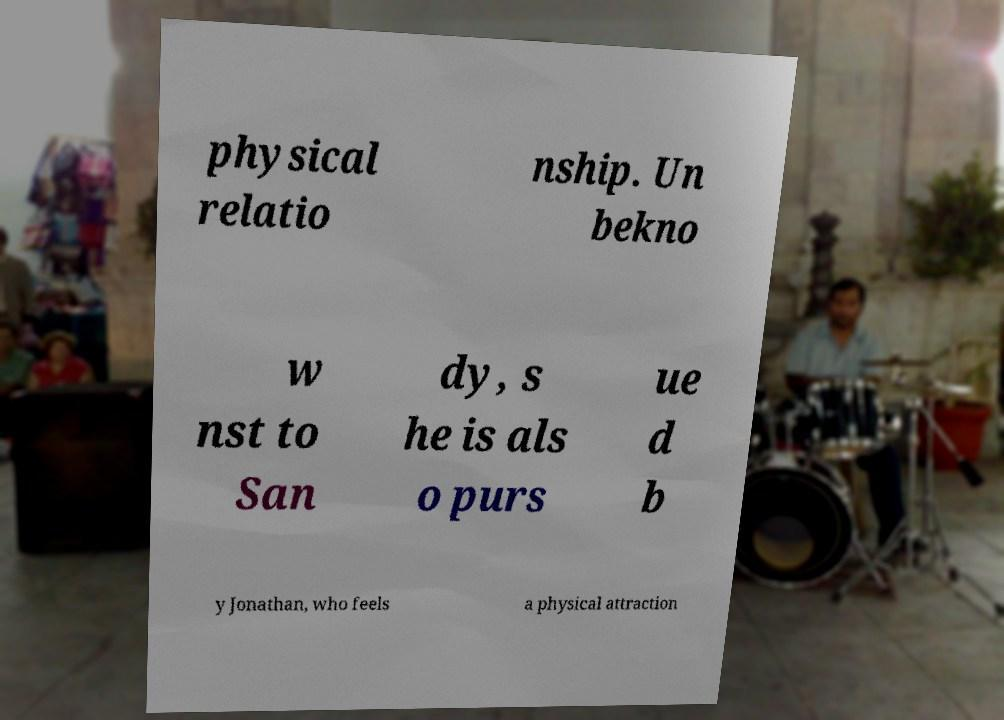I need the written content from this picture converted into text. Can you do that? physical relatio nship. Un bekno w nst to San dy, s he is als o purs ue d b y Jonathan, who feels a physical attraction 